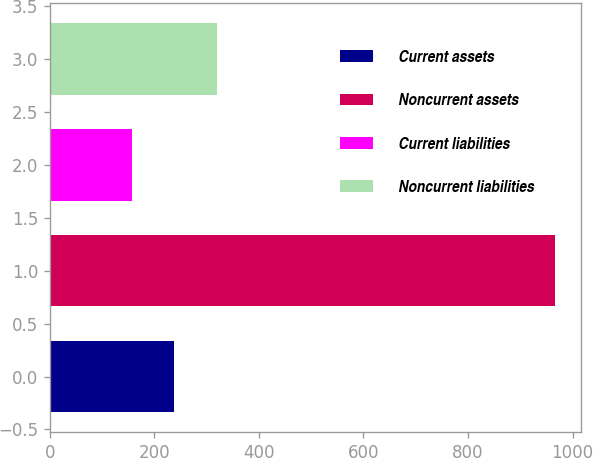Convert chart. <chart><loc_0><loc_0><loc_500><loc_500><bar_chart><fcel>Current assets<fcel>Noncurrent assets<fcel>Current liabilities<fcel>Noncurrent liabilities<nl><fcel>238<fcel>967<fcel>157<fcel>319<nl></chart> 